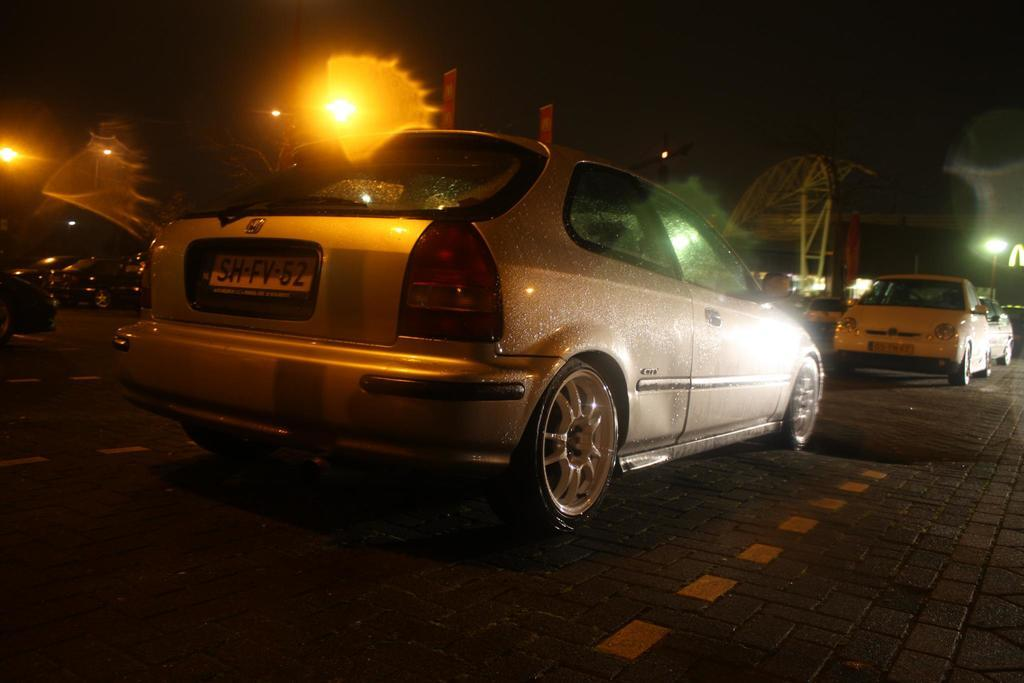What type of vehicles can be seen on the road in the image? There are cars on the road in the image. What else is visible in the image besides the cars? There are lights and a tower crane visible in the image. Can you describe the object in the image? There is an object in the image, but its specific details are not mentioned in the provided facts. What is the color of the background in the image? The background of the image is dark. What sound does the crow make while sitting on the pot in the image? There is no crow or pot present in the image, so this scenario cannot be observed. 